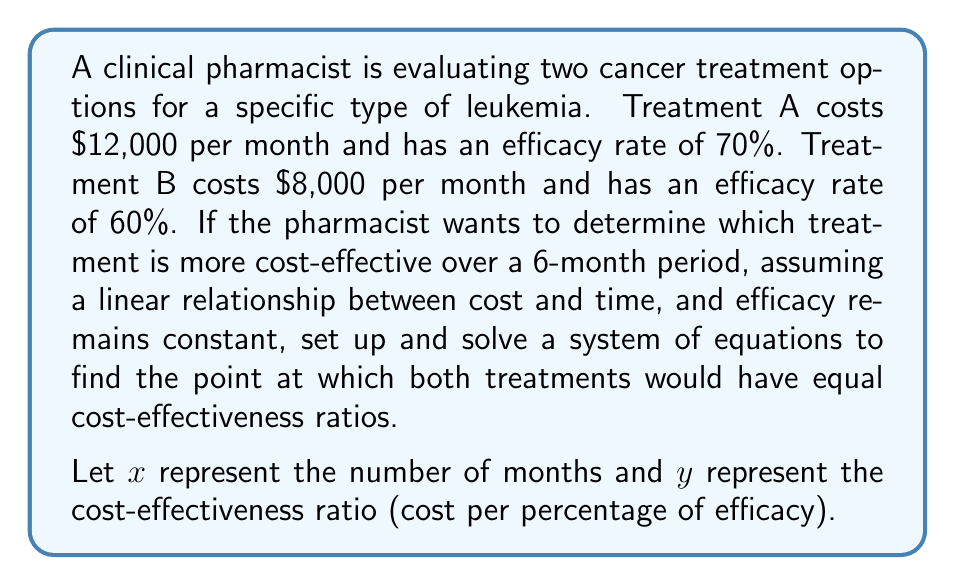Show me your answer to this math problem. To solve this problem, we need to set up equations for the cost-effectiveness ratio of each treatment and then find the point where they are equal.

1. Set up equations for each treatment:

   Treatment A: $y = \frac{12000x}{70}$
   Treatment B: $y = \frac{8000x}{60}$

2. Set the equations equal to each other:

   $\frac{12000x}{70} = \frac{8000x}{60}$

3. Cross-multiply:

   $12000x \cdot 60 = 8000x \cdot 70$

4. Simplify:

   $720000x = 560000x$

5. Subtract $560000x$ from both sides:

   $160000x = 0$

6. Divide both sides by 160000:

   $x = 0$

7. Since $x = 0$ is not a meaningful solution in this context, we can conclude that one treatment is always more cost-effective than the other.

8. To determine which treatment is more cost-effective, let's calculate the cost-effectiveness ratio for each treatment at 6 months:

   Treatment A: $\frac{12000 \cdot 6}{70} = \frac{72000}{70} \approx 1028.57$
   Treatment B: $\frac{8000 \cdot 6}{60} = \frac{48000}{60} = 800$

9. Treatment B has a lower cost-effectiveness ratio, meaning it is more cost-effective.
Answer: Treatment B is more cost-effective throughout the entire 6-month period, with a cost-effectiveness ratio of $800 per percentage of efficacy compared to Treatment A's ratio of approximately $1028.57 per percentage of efficacy. 